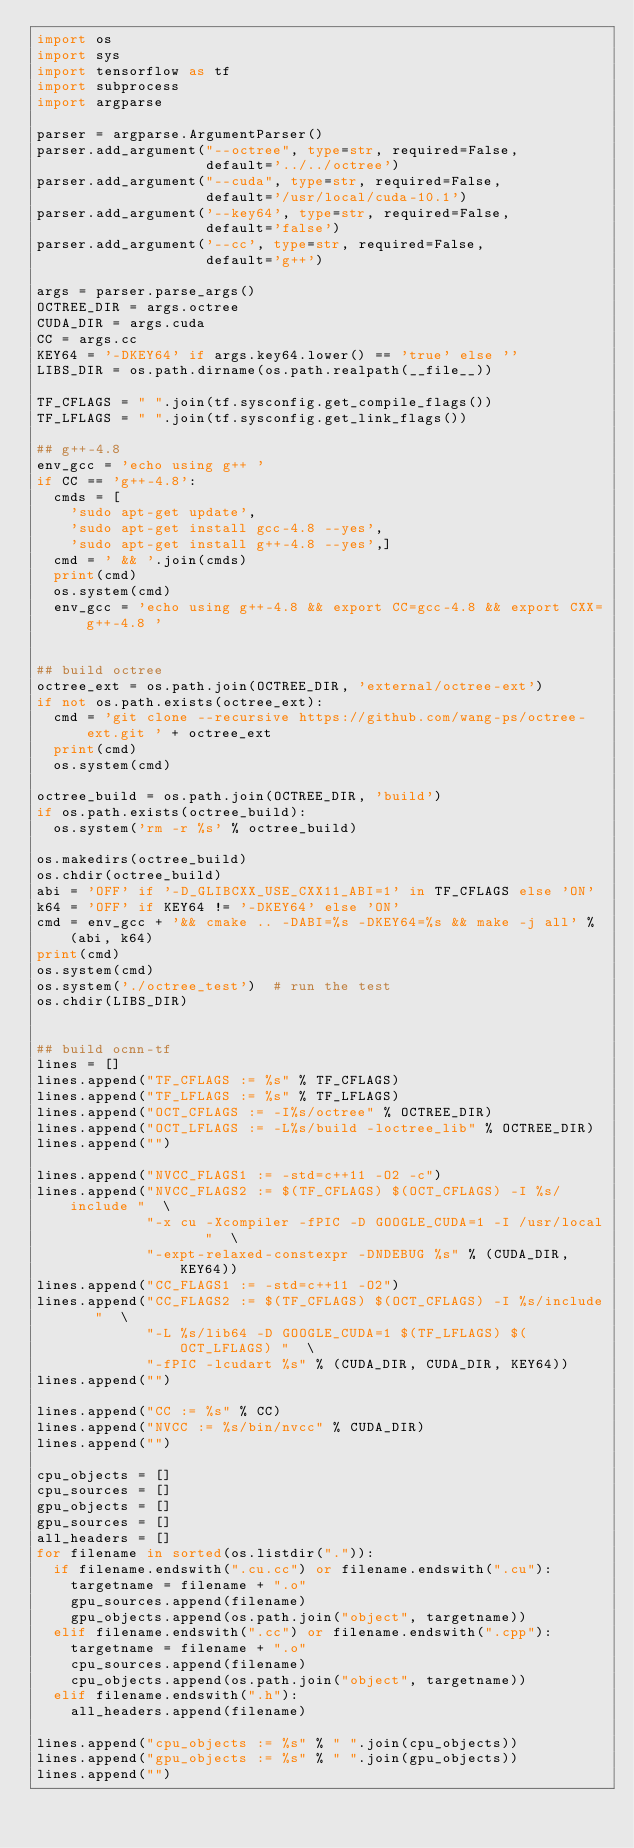<code> <loc_0><loc_0><loc_500><loc_500><_Python_>import os
import sys
import tensorflow as tf
import subprocess
import argparse

parser = argparse.ArgumentParser()
parser.add_argument("--octree", type=str, required=False,
                    default='../../octree')
parser.add_argument("--cuda", type=str, required=False,
                    default='/usr/local/cuda-10.1')
parser.add_argument('--key64', type=str, required=False,
                    default='false')
parser.add_argument('--cc', type=str, required=False,
                    default='g++')

args = parser.parse_args()
OCTREE_DIR = args.octree
CUDA_DIR = args.cuda
CC = args.cc
KEY64 = '-DKEY64' if args.key64.lower() == 'true' else ''
LIBS_DIR = os.path.dirname(os.path.realpath(__file__))

TF_CFLAGS = " ".join(tf.sysconfig.get_compile_flags())
TF_LFLAGS = " ".join(tf.sysconfig.get_link_flags())

## g++-4.8
env_gcc = 'echo using g++ '
if CC == 'g++-4.8':
  cmds = [
    'sudo apt-get update',
    'sudo apt-get install gcc-4.8 --yes',
    'sudo apt-get install g++-4.8 --yes',]
  cmd = ' && '.join(cmds)
  print(cmd)
  os.system(cmd)
  env_gcc = 'echo using g++-4.8 && export CC=gcc-4.8 && export CXX=g++-4.8 '


## build octree
octree_ext = os.path.join(OCTREE_DIR, 'external/octree-ext')
if not os.path.exists(octree_ext):
  cmd = 'git clone --recursive https://github.com/wang-ps/octree-ext.git ' + octree_ext
  print(cmd)
  os.system(cmd)

octree_build = os.path.join(OCTREE_DIR, 'build')
if os.path.exists(octree_build):
  os.system('rm -r %s' % octree_build)

os.makedirs(octree_build)
os.chdir(octree_build)
abi = 'OFF' if '-D_GLIBCXX_USE_CXX11_ABI=1' in TF_CFLAGS else 'ON'
k64 = 'OFF' if KEY64 != '-DKEY64' else 'ON'
cmd = env_gcc + '&& cmake .. -DABI=%s -DKEY64=%s && make -j all' % (abi, k64)
print(cmd)
os.system(cmd)
os.system('./octree_test')  # run the test
os.chdir(LIBS_DIR)


## build ocnn-tf
lines = []
lines.append("TF_CFLAGS := %s" % TF_CFLAGS)
lines.append("TF_LFLAGS := %s" % TF_LFLAGS)
lines.append("OCT_CFLAGS := -I%s/octree" % OCTREE_DIR)
lines.append("OCT_LFLAGS := -L%s/build -loctree_lib" % OCTREE_DIR)
lines.append("")

lines.append("NVCC_FLAGS1 := -std=c++11 -O2 -c")
lines.append("NVCC_FLAGS2 := $(TF_CFLAGS) $(OCT_CFLAGS) -I %s/include "  \
             "-x cu -Xcompiler -fPIC -D GOOGLE_CUDA=1 -I /usr/local   "  \
             "-expt-relaxed-constexpr -DNDEBUG %s" % (CUDA_DIR, KEY64))
lines.append("CC_FLAGS1 := -std=c++11 -O2")
lines.append("CC_FLAGS2 := $(TF_CFLAGS) $(OCT_CFLAGS) -I %s/include   "  \
             "-L %s/lib64 -D GOOGLE_CUDA=1 $(TF_LFLAGS) $(OCT_LFLAGS) "  \
             "-fPIC -lcudart %s" % (CUDA_DIR, CUDA_DIR, KEY64))
lines.append("")

lines.append("CC := %s" % CC)
lines.append("NVCC := %s/bin/nvcc" % CUDA_DIR)
lines.append("")

cpu_objects = []
cpu_sources = []
gpu_objects = []
gpu_sources = []
all_headers = []
for filename in sorted(os.listdir(".")):
  if filename.endswith(".cu.cc") or filename.endswith(".cu"):
    targetname = filename + ".o"
    gpu_sources.append(filename)
    gpu_objects.append(os.path.join("object", targetname))
  elif filename.endswith(".cc") or filename.endswith(".cpp"):
    targetname = filename + ".o"
    cpu_sources.append(filename)
    cpu_objects.append(os.path.join("object", targetname))
  elif filename.endswith(".h"):
    all_headers.append(filename)

lines.append("cpu_objects := %s" % " ".join(cpu_objects))
lines.append("gpu_objects := %s" % " ".join(gpu_objects))
lines.append("")
</code> 